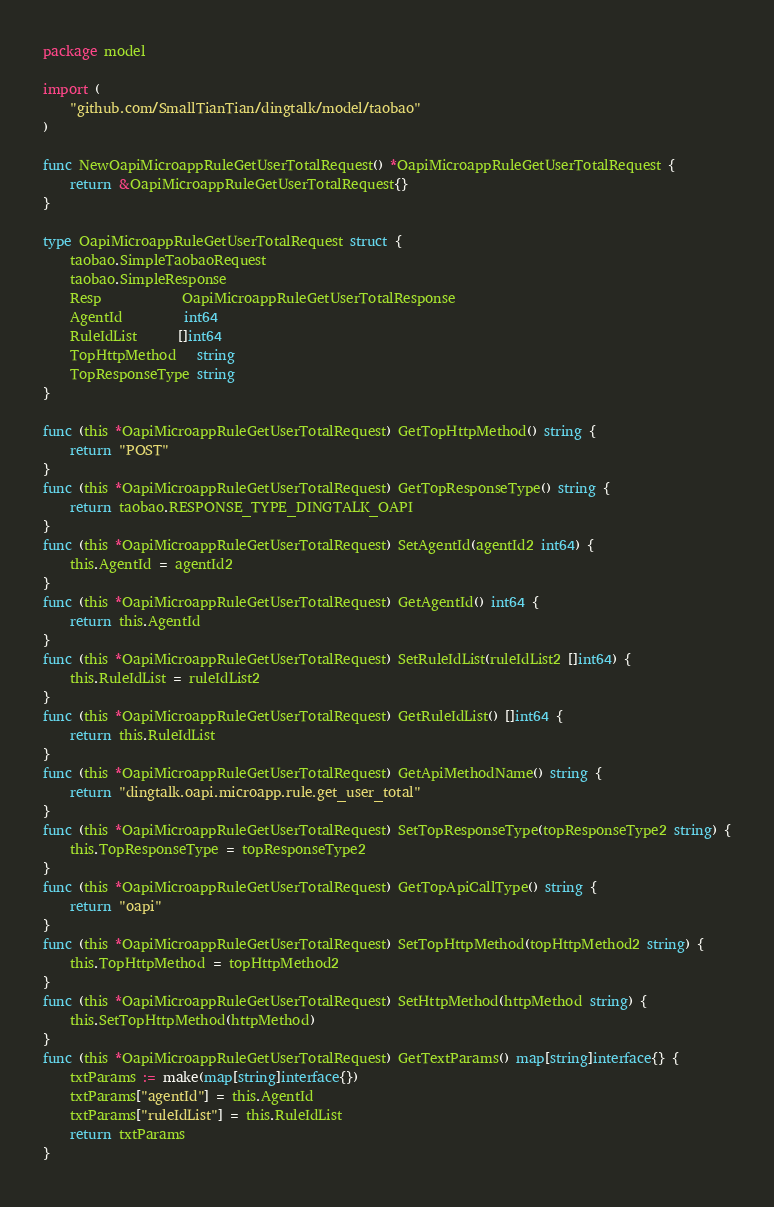Convert code to text. <code><loc_0><loc_0><loc_500><loc_500><_Go_>package model

import (
	"github.com/SmallTianTian/dingtalk/model/taobao"
)

func NewOapiMicroappRuleGetUserTotalRequest() *OapiMicroappRuleGetUserTotalRequest {
	return &OapiMicroappRuleGetUserTotalRequest{}
}

type OapiMicroappRuleGetUserTotalRequest struct {
	taobao.SimpleTaobaoRequest
	taobao.SimpleResponse
	Resp            OapiMicroappRuleGetUserTotalResponse
	AgentId         int64
	RuleIdList      []int64
	TopHttpMethod   string
	TopResponseType string
}

func (this *OapiMicroappRuleGetUserTotalRequest) GetTopHttpMethod() string {
	return "POST"
}
func (this *OapiMicroappRuleGetUserTotalRequest) GetTopResponseType() string {
	return taobao.RESPONSE_TYPE_DINGTALK_OAPI
}
func (this *OapiMicroappRuleGetUserTotalRequest) SetAgentId(agentId2 int64) {
	this.AgentId = agentId2
}
func (this *OapiMicroappRuleGetUserTotalRequest) GetAgentId() int64 {
	return this.AgentId
}
func (this *OapiMicroappRuleGetUserTotalRequest) SetRuleIdList(ruleIdList2 []int64) {
	this.RuleIdList = ruleIdList2
}
func (this *OapiMicroappRuleGetUserTotalRequest) GetRuleIdList() []int64 {
	return this.RuleIdList
}
func (this *OapiMicroappRuleGetUserTotalRequest) GetApiMethodName() string {
	return "dingtalk.oapi.microapp.rule.get_user_total"
}
func (this *OapiMicroappRuleGetUserTotalRequest) SetTopResponseType(topResponseType2 string) {
	this.TopResponseType = topResponseType2
}
func (this *OapiMicroappRuleGetUserTotalRequest) GetTopApiCallType() string {
	return "oapi"
}
func (this *OapiMicroappRuleGetUserTotalRequest) SetTopHttpMethod(topHttpMethod2 string) {
	this.TopHttpMethod = topHttpMethod2
}
func (this *OapiMicroappRuleGetUserTotalRequest) SetHttpMethod(httpMethod string) {
	this.SetTopHttpMethod(httpMethod)
}
func (this *OapiMicroappRuleGetUserTotalRequest) GetTextParams() map[string]interface{} {
	txtParams := make(map[string]interface{})
	txtParams["agentId"] = this.AgentId
	txtParams["ruleIdList"] = this.RuleIdList
	return txtParams
}</code> 